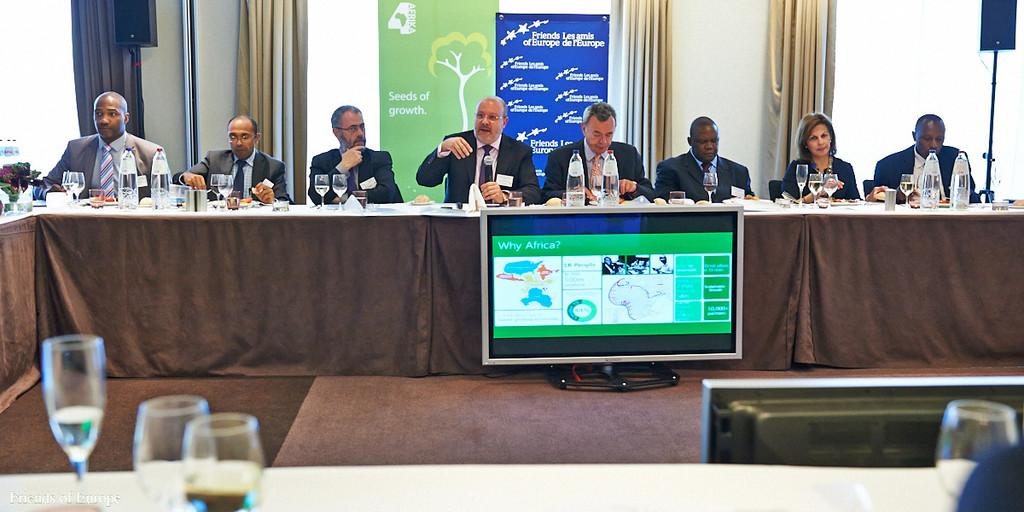<image>
Offer a succinct explanation of the picture presented. People having a meeting in front of a blue sign that says "Friends Les amis of Europe". 